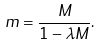Convert formula to latex. <formula><loc_0><loc_0><loc_500><loc_500>m = \frac { M } { 1 - \lambda M } .</formula> 